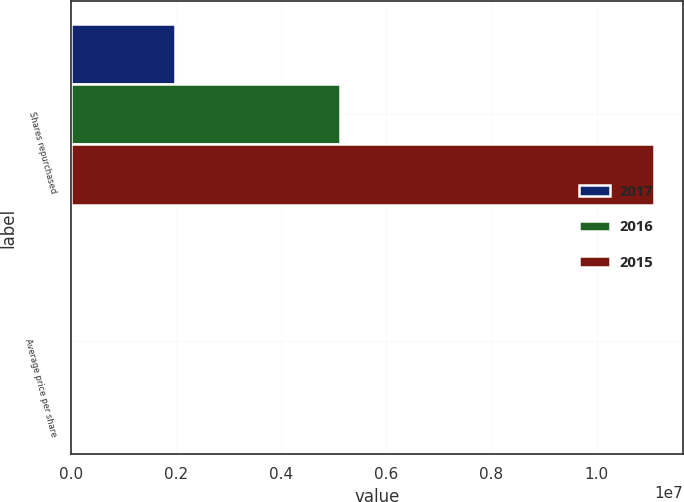<chart> <loc_0><loc_0><loc_500><loc_500><stacked_bar_chart><ecel><fcel>Shares repurchased<fcel>Average price per share<nl><fcel>2017<fcel>1.97678e+06<fcel>133.9<nl><fcel>2016<fcel>5.12105e+06<fcel>108.87<nl><fcel>2015<fcel>1.10918e+07<fcel>125.64<nl></chart> 